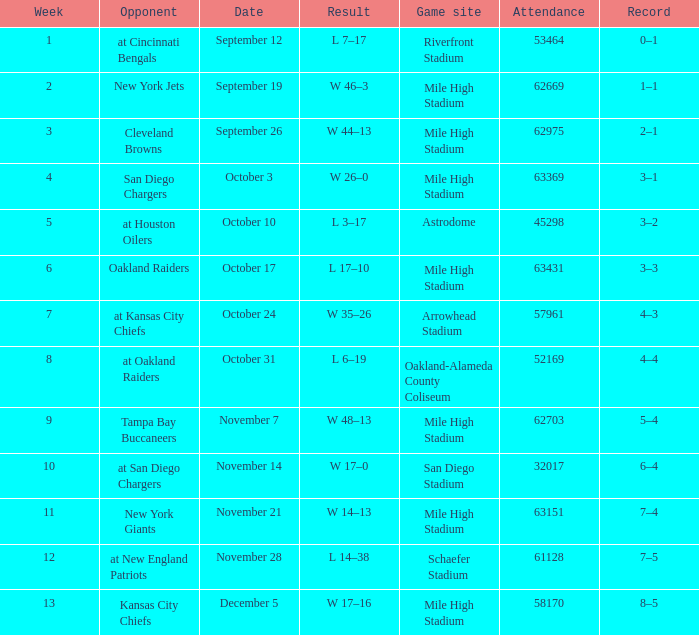What was the date of the week 4 game? October 3. 